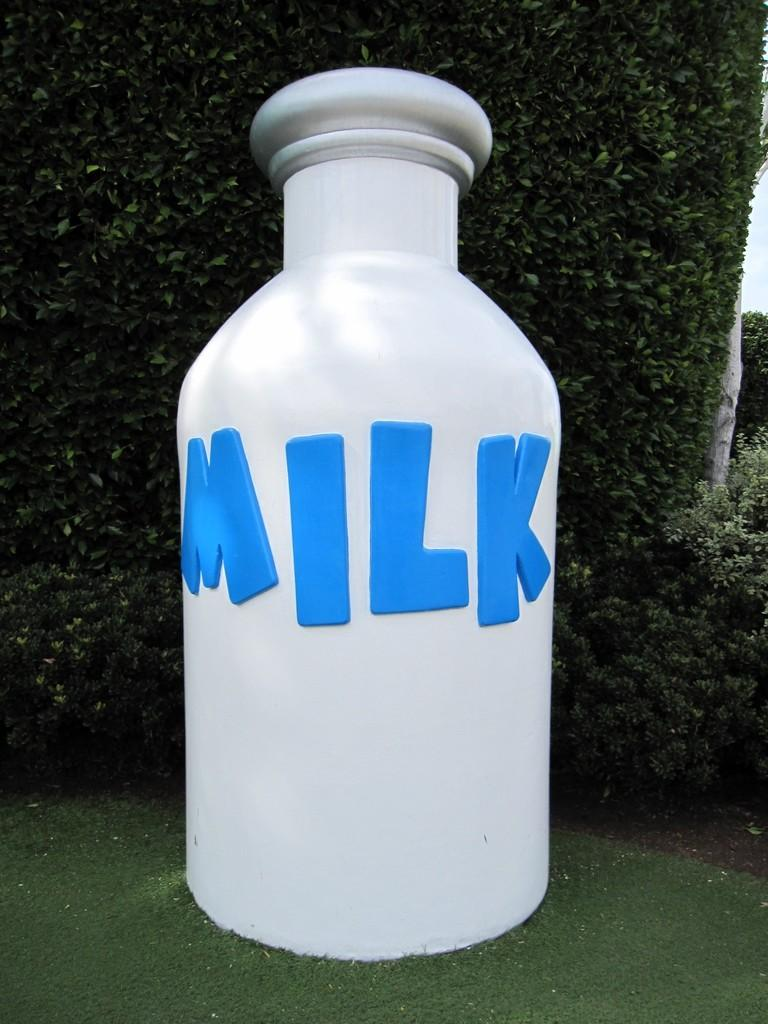<image>
Render a clear and concise summary of the photo. A giant white milk bottle has blue lettering. 